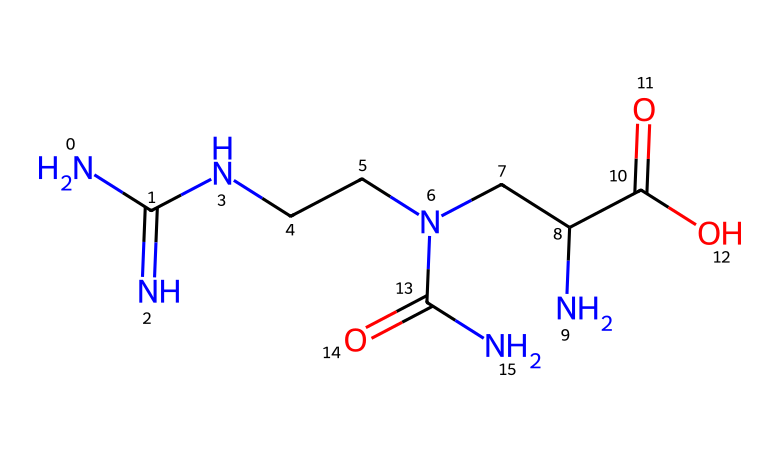What is the molecular formula of this chemical? By examining the SMILES representation, we can count the types and number of atoms present: there are 6 carbon (C), 14 hydrogen (H), 4 nitrogen (N), and 4 oxygen (O) atoms, giving us the molecular formula C6H14N4O4.
Answer: C6H14N4O4 How many nitrogen atoms are present in the compound? The SMILES representation shows that there are four nitrogen (N) atoms in the structure, which can be counted directly from the formula in the representation.
Answer: 4 What type of functional groups are present in this chemical? Analyzing the SMILES, we can identify that the compound contains amide groups (-C(=O)N-) and carboxylic acids (-C(=O)O), indicating the presence of both types of functional groups.
Answer: amide and carboxylic acid What is the role of this compound in energy production? Creatine helps regenerate ATP (adenosine triphosphate), which is the primary energy carrier in cells, particularly during high-intensity exercise, by donating a phosphate group to ADP (adenosine diphosphate).
Answer: ATP regeneration How does the structure of creatine relate to its energy-providing capabilities? The structure has a guanidine group, which is crucial for its ability to donate a phosphate group, facilitating the rapid replenishment of ATP from ADP, essential for explosive energy needs in sports.
Answer: guanidine group What is the significance of the carboxylic acid group in creatine? The presence of the carboxylic acid group (-C(=O)O) contributes to the solubility of creatine in water, which is significant for its transport in the bloodstream to muscle tissues where it is utilized for energy.
Answer: solubility 